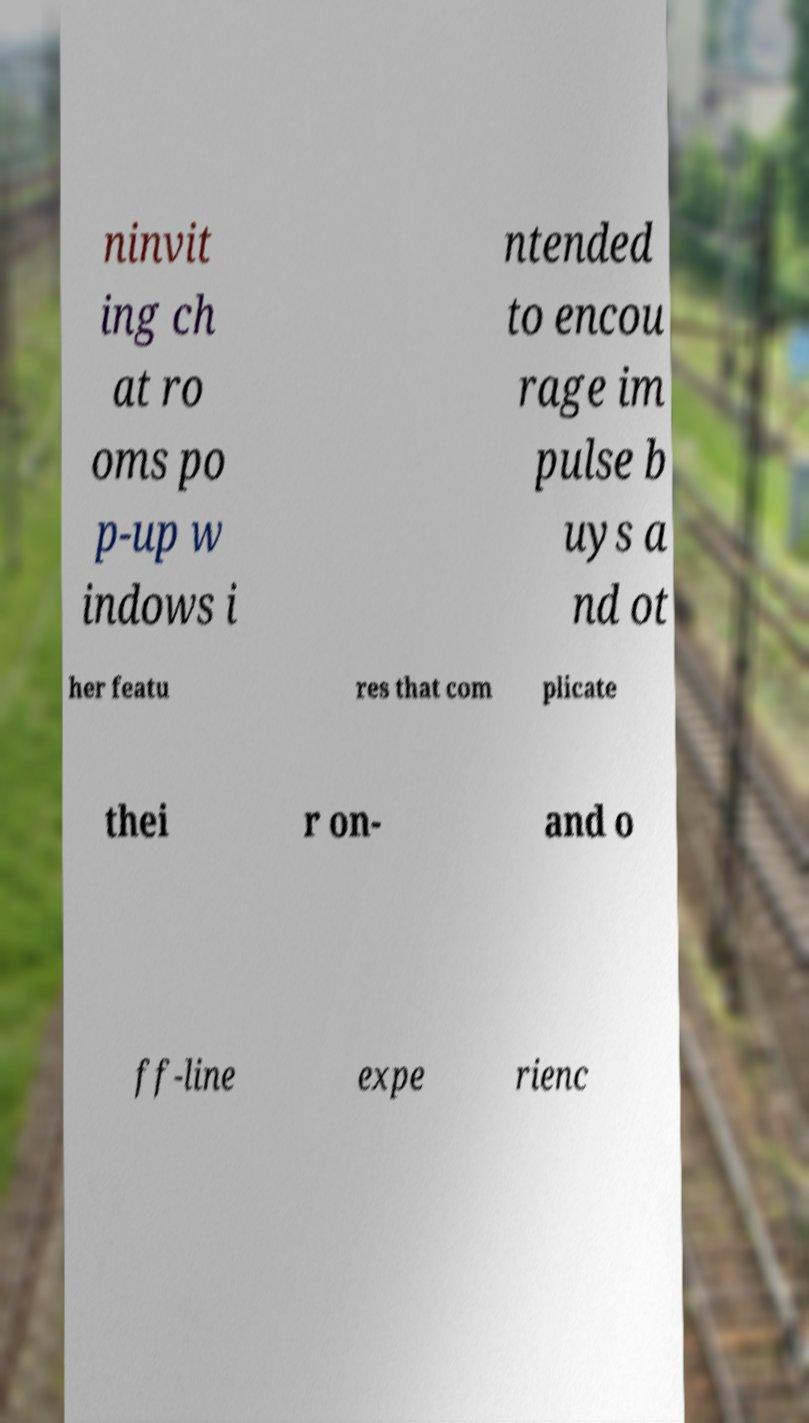There's text embedded in this image that I need extracted. Can you transcribe it verbatim? ninvit ing ch at ro oms po p-up w indows i ntended to encou rage im pulse b uys a nd ot her featu res that com plicate thei r on- and o ff-line expe rienc 